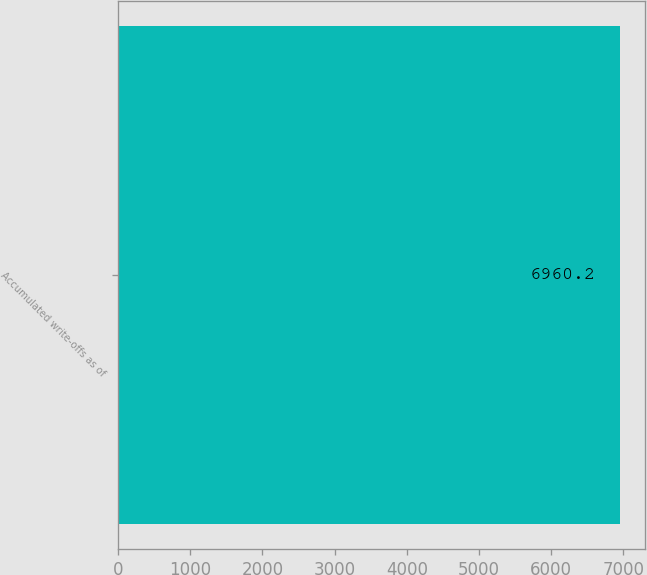<chart> <loc_0><loc_0><loc_500><loc_500><bar_chart><fcel>Accumulated write-offs as of<nl><fcel>6960.2<nl></chart> 